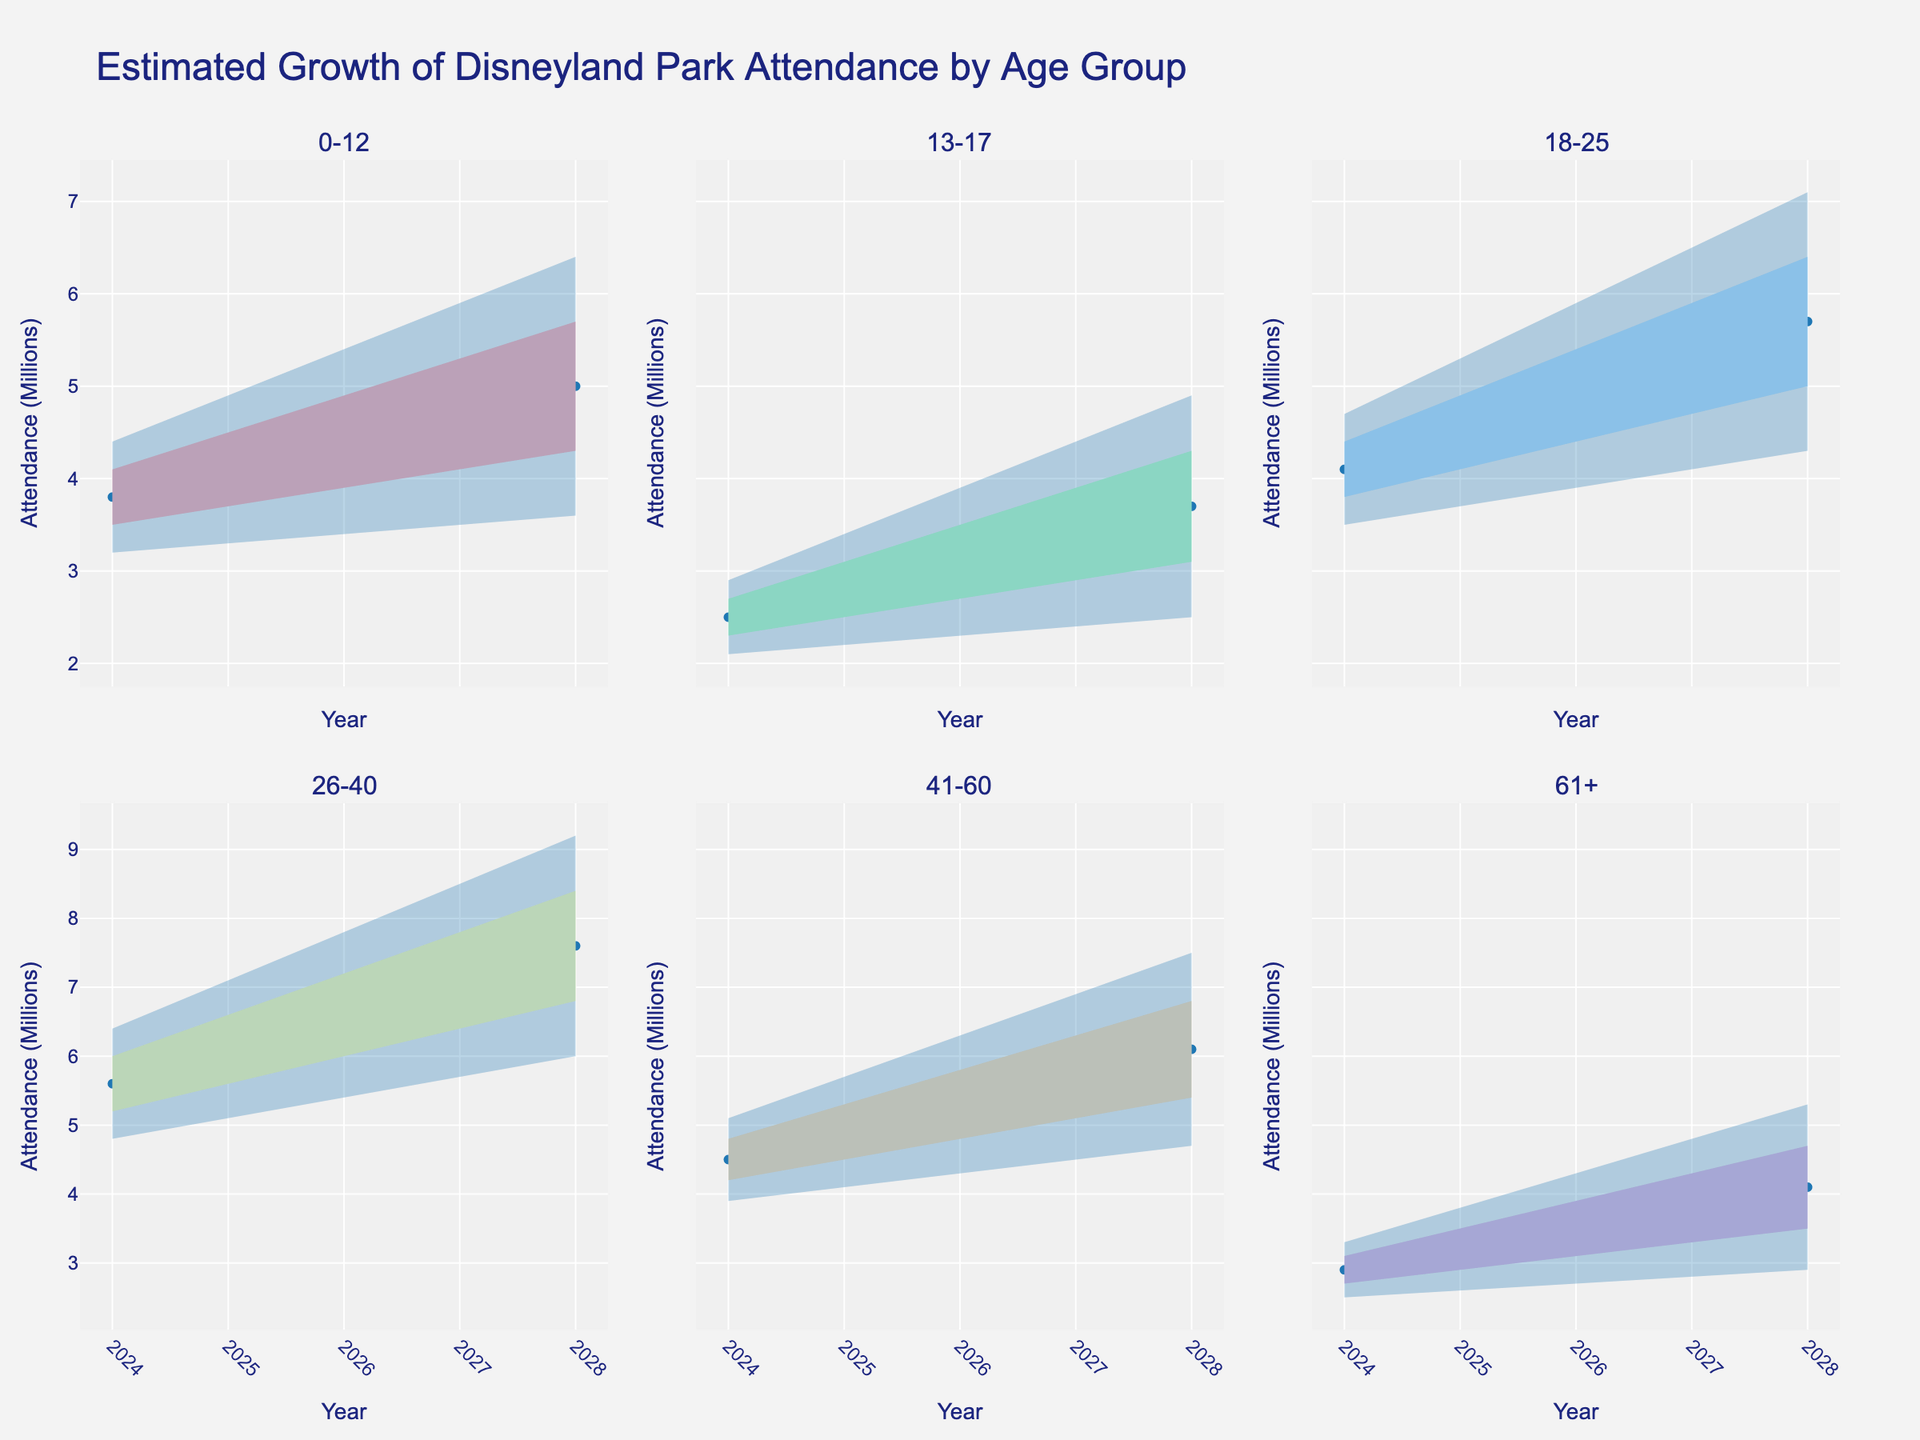What is the title of the figure? The title is usually located at the top of the figure and provides a summary of what the figure is about.
Answer: Estimated Growth of Disneyland Park Attendance by Age Group How many age groups are represented in the figure? Each subplot corresponds to an age group. Count the number of subplot titles to get the total number of age groups.
Answer: Six Which age group has the highest mid estimate for attendance in 2028? Look at the subplot titles and find the subplot that represents the age group with the highest mid estimate for 2028. Check the values on the y-axis for 2028.
Answer: 26-40 What is the range of the mid estimate for the 0-12 age group from 2024 to 2028? Identify the mid estimate values for 2024 and 2028 from the subplot for the 0-12 age group and calculate the difference. The range is given by the maximum value minus the minimum value.
Answer: 1.2 million (5.0 - 3.8) How does the attendance estimate for the 61+ age group in 2027 compare to 2028? Look at the subplot for the 61+ age group and compare the mid estimate values for 2027 and 2028.
Answer: It increases What is the average attendance mid estimate for the 18-25 age group from 2024 to 2028? Identify the mid estimate values from each year (2024 to 2028) for the 18-25 age group and calculate the average. Add all the values together and divide by the number of years.
Answer: 4.9 million ((4.1+4.5+4.9+5.3+5.7)/5) Which year shows the lowest attendance estimate for the 13-17 age group? Check the subplot for the 13-17 age group and find the year with the lowest mid estimate value.
Answer: 2024 What is the trend in the attendance for the 41-60 age group from 2024 to 2028? Examine the subplot for the 41-60 age group and observe whether the mid estimate values increase, decrease, or remain stable over the years.
Answer: Increasing Are the estimates for the 26-40 age group consistently higher than those for the 0-12 age group? Compare the values in both subplots (26-40 and 0-12) for all years and check if the 26-40 age group's estimates are always higher.
Answer: Yes Which age group shows the smallest increase in attendance from 2024 to 2028? Calculate the difference in mid estimates from 2024 to 2028 for all age groups and identify the group with the smallest increase.
Answer: 61+ 